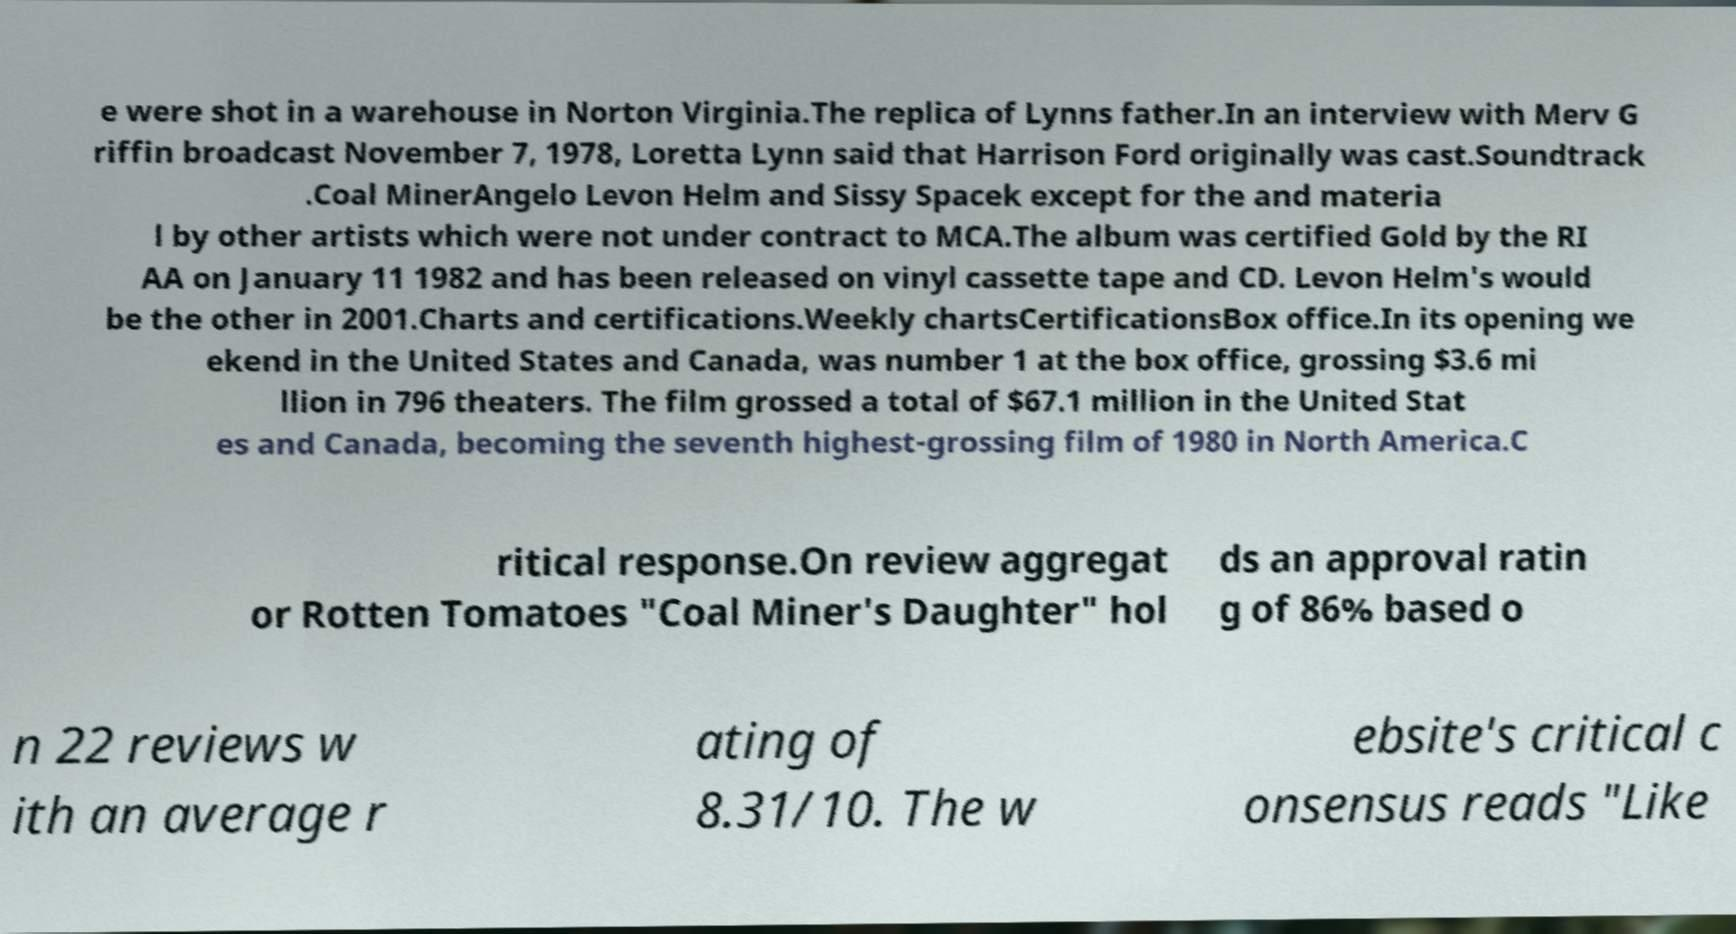For documentation purposes, I need the text within this image transcribed. Could you provide that? e were shot in a warehouse in Norton Virginia.The replica of Lynns father.In an interview with Merv G riffin broadcast November 7, 1978, Loretta Lynn said that Harrison Ford originally was cast.Soundtrack .Coal MinerAngelo Levon Helm and Sissy Spacek except for the and materia l by other artists which were not under contract to MCA.The album was certified Gold by the RI AA on January 11 1982 and has been released on vinyl cassette tape and CD. Levon Helm's would be the other in 2001.Charts and certifications.Weekly chartsCertificationsBox office.In its opening we ekend in the United States and Canada, was number 1 at the box office, grossing $3.6 mi llion in 796 theaters. The film grossed a total of $67.1 million in the United Stat es and Canada, becoming the seventh highest-grossing film of 1980 in North America.C ritical response.On review aggregat or Rotten Tomatoes "Coal Miner's Daughter" hol ds an approval ratin g of 86% based o n 22 reviews w ith an average r ating of 8.31/10. The w ebsite's critical c onsensus reads "Like 